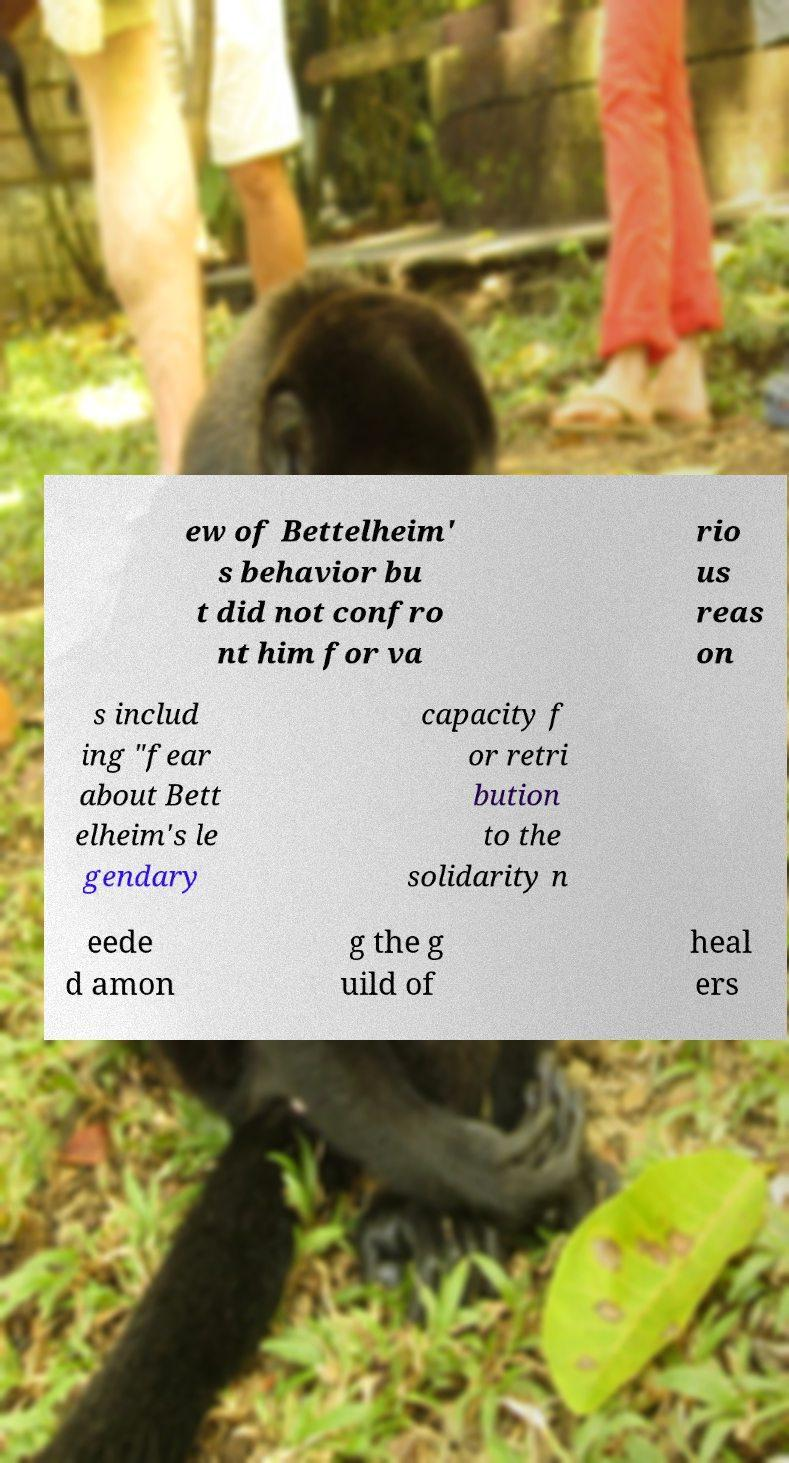Can you read and provide the text displayed in the image?This photo seems to have some interesting text. Can you extract and type it out for me? ew of Bettelheim' s behavior bu t did not confro nt him for va rio us reas on s includ ing "fear about Bett elheim's le gendary capacity f or retri bution to the solidarity n eede d amon g the g uild of heal ers 